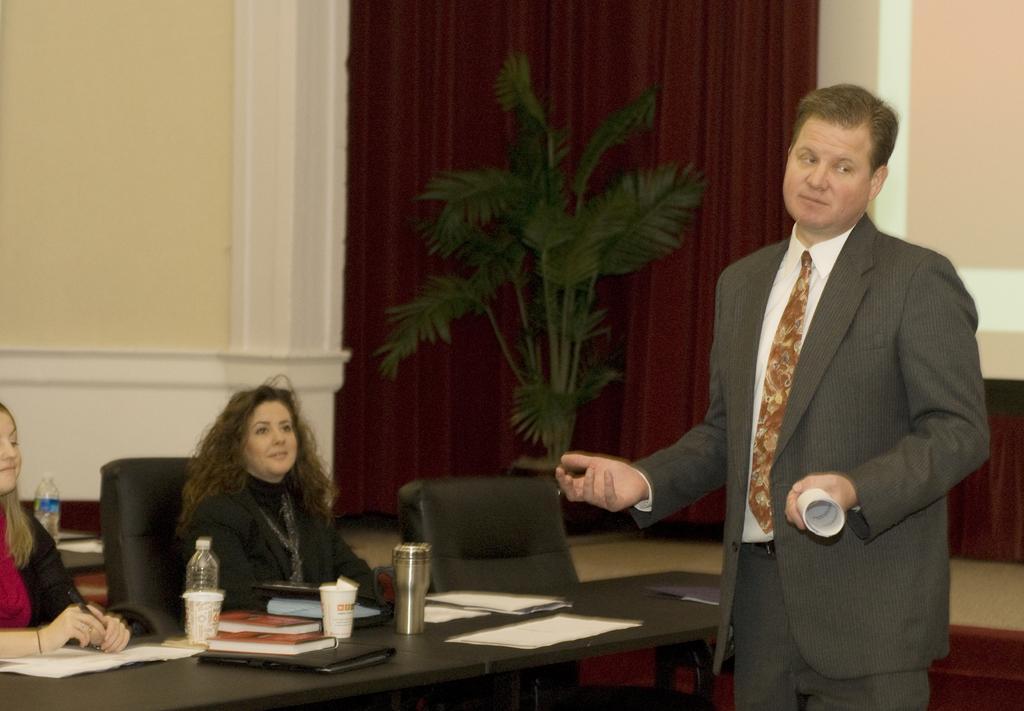How would you summarize this image in a sentence or two? In this image there is a person standing and holding a paper, and in the background there are two persons sitting on the cars, there are bottles, papers, books and glasses on the tables, curtains, plant,wall. 